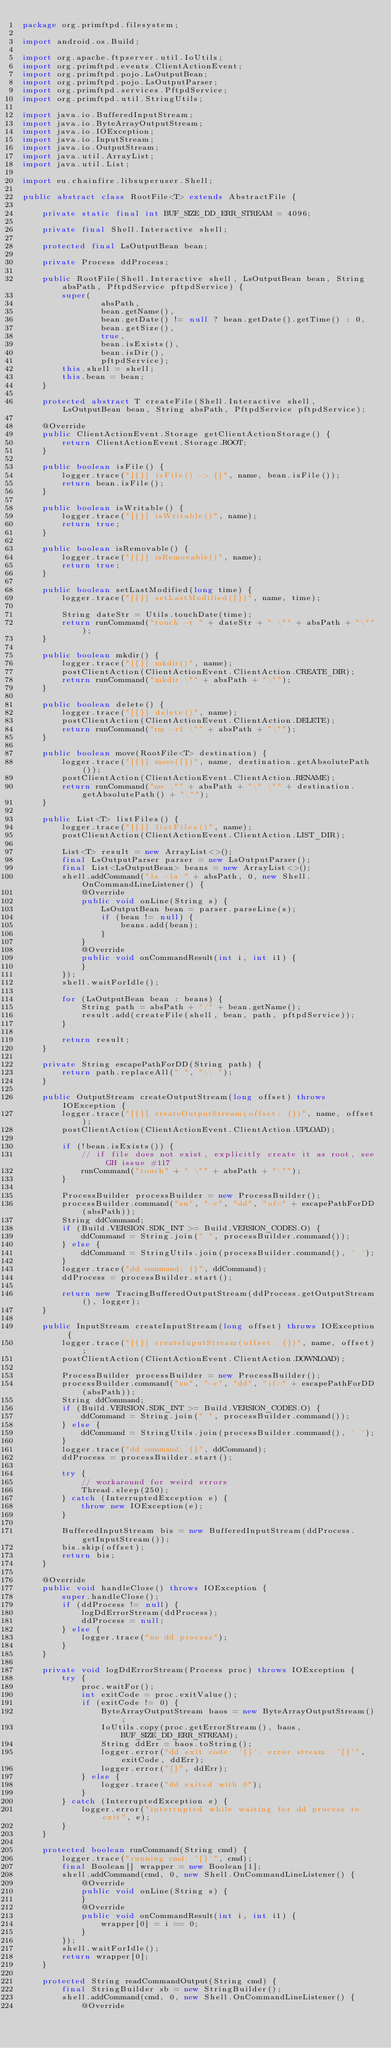Convert code to text. <code><loc_0><loc_0><loc_500><loc_500><_Java_>package org.primftpd.filesystem;

import android.os.Build;

import org.apache.ftpserver.util.IoUtils;
import org.primftpd.events.ClientActionEvent;
import org.primftpd.pojo.LsOutputBean;
import org.primftpd.pojo.LsOutputParser;
import org.primftpd.services.PftpdService;
import org.primftpd.util.StringUtils;

import java.io.BufferedInputStream;
import java.io.ByteArrayOutputStream;
import java.io.IOException;
import java.io.InputStream;
import java.io.OutputStream;
import java.util.ArrayList;
import java.util.List;

import eu.chainfire.libsuperuser.Shell;

public abstract class RootFile<T> extends AbstractFile {

    private static final int BUF_SIZE_DD_ERR_STREAM = 4096;

    private final Shell.Interactive shell;

    protected final LsOutputBean bean;

    private Process ddProcess;

    public RootFile(Shell.Interactive shell, LsOutputBean bean, String absPath, PftpdService pftpdService) {
        super(
                absPath,
                bean.getName(),
                bean.getDate() != null ? bean.getDate().getTime() : 0,
                bean.getSize(),
                true,
                bean.isExists(),
                bean.isDir(),
                pftpdService);
        this.shell = shell;
        this.bean = bean;
    }

    protected abstract T createFile(Shell.Interactive shell, LsOutputBean bean, String absPath, PftpdService pftpdService);

    @Override
    public ClientActionEvent.Storage getClientActionStorage() {
        return ClientActionEvent.Storage.ROOT;
    }

    public boolean isFile() {
        logger.trace("[{}] isFile() -> {}", name, bean.isFile());
        return bean.isFile();
    }

    public boolean isWritable() {
        logger.trace("[{}] isWritable()", name);
        return true;
    }

    public boolean isRemovable() {
        logger.trace("[{}] isRemovable()", name);
        return true;
    }

    public boolean setLastModified(long time) {
        logger.trace("[{}] setLastModified({})", name, time);

        String dateStr = Utils.touchDate(time);
        return runCommand("touch -t " + dateStr + " \"" + absPath + "\"");
    }

    public boolean mkdir() {
        logger.trace("[{}] mkdir()", name);
        postClientAction(ClientActionEvent.ClientAction.CREATE_DIR);
        return runCommand("mkdir \"" + absPath + "\"");
    }

    public boolean delete() {
        logger.trace("[{}] delete()", name);
        postClientAction(ClientActionEvent.ClientAction.DELETE);
        return runCommand("rm -rf \"" + absPath + "\"");
    }

    public boolean move(RootFile<T> destination) {
        logger.trace("[{}] move({})", name, destination.getAbsolutePath());
        postClientAction(ClientActionEvent.ClientAction.RENAME);
        return runCommand("mv \"" + absPath + "\" \"" + destination.getAbsolutePath() + "\"");
    }

    public List<T> listFiles() {
        logger.trace("[{}] listFiles()", name);
        postClientAction(ClientActionEvent.ClientAction.LIST_DIR);

        List<T> result = new ArrayList<>();
        final LsOutputParser parser = new LsOutputParser();
        final List<LsOutputBean> beans = new ArrayList<>();
        shell.addCommand("ls -la " + absPath, 0, new Shell.OnCommandLineListener() {
            @Override
            public void onLine(String s) {
                LsOutputBean bean = parser.parseLine(s);
                if (bean != null) {
                    beans.add(bean);
                }
            }
            @Override
            public void onCommandResult(int i, int i1) {
            }
        });
        shell.waitForIdle();

        for (LsOutputBean bean : beans) {
            String path = absPath + "/" + bean.getName();
            result.add(createFile(shell, bean, path, pftpdService));
        }

        return result;
    }

    private String escapePathForDD(String path) {
        return path.replaceAll(" ", "\\ ");
    }

    public OutputStream createOutputStream(long offset) throws IOException {
        logger.trace("[{}] createOutputStream(offset: {})", name, offset);
        postClientAction(ClientActionEvent.ClientAction.UPLOAD);

        if (!bean.isExists()) {
            // if file does not exist, explicitly create it as root, see GH issue #117
            runCommand("touch" + " \"" + absPath + "\"");
        }

        ProcessBuilder processBuilder = new ProcessBuilder();
        processBuilder.command("su", "-c", "dd", "of=" + escapePathForDD(absPath));
        String ddCommand;
        if (Build.VERSION.SDK_INT >= Build.VERSION_CODES.O) {
            ddCommand = String.join(" ", processBuilder.command());
        } else {
            ddCommand = StringUtils.join(processBuilder.command(), ' ');
        }
        logger.trace("dd command: {}", ddCommand);
        ddProcess = processBuilder.start();

        return new TracingBufferedOutputStream(ddProcess.getOutputStream(), logger);
    }

    public InputStream createInputStream(long offset) throws IOException {
        logger.trace("[{}] createInputStream(offset: {})", name, offset);
        postClientAction(ClientActionEvent.ClientAction.DOWNLOAD);

        ProcessBuilder processBuilder = new ProcessBuilder();
        processBuilder.command("su", "-c", "dd", "if=" + escapePathForDD(absPath));
        String ddCommand;
        if (Build.VERSION.SDK_INT >= Build.VERSION_CODES.O) {
            ddCommand = String.join(" ", processBuilder.command());
        } else {
            ddCommand = StringUtils.join(processBuilder.command(), ' ');
        }
        logger.trace("dd command: {}", ddCommand);
        ddProcess = processBuilder.start();

        try {
            // workaround for weird errors
            Thread.sleep(250);
        } catch (InterruptedException e) {
            throw new IOException(e);
        }

        BufferedInputStream bis = new BufferedInputStream(ddProcess.getInputStream());
        bis.skip(offset);
        return bis;
    }

    @Override
    public void handleClose() throws IOException {
        super.handleClose();
        if (ddProcess != null) {
            logDdErrorStream(ddProcess);
            ddProcess = null;
        } else {
            logger.trace("no dd process");
        }
    }

    private void logDdErrorStream(Process proc) throws IOException {
        try {
            proc.waitFor();
            int exitCode = proc.exitValue();
            if (exitCode != 0) {
                ByteArrayOutputStream baos = new ByteArrayOutputStream();
                IoUtils.copy(proc.getErrorStream(), baos, BUF_SIZE_DD_ERR_STREAM);
                String ddErr = baos.toString();
                logger.error("dd exit code: '{}', error stream: '{}'", exitCode, ddErr);
                logger.error("{}", ddErr);
            } else {
                logger.trace("dd exited with 0");
            }
        } catch (InterruptedException e) {
            logger.error("interrupted while waiting for dd process to exit", e);
        }
    }

    protected boolean runCommand(String cmd) {
        logger.trace("running cmd: '{}'", cmd);
        final Boolean[] wrapper = new Boolean[1];
        shell.addCommand(cmd, 0, new Shell.OnCommandLineListener() {
            @Override
            public void onLine(String s) {
            }
            @Override
            public void onCommandResult(int i, int i1) {
                wrapper[0] = i == 0;
            }
        });
        shell.waitForIdle();
        return wrapper[0];
    }

    protected String readCommandOutput(String cmd) {
        final StringBuilder sb = new StringBuilder();
        shell.addCommand(cmd, 0, new Shell.OnCommandLineListener() {
            @Override</code> 